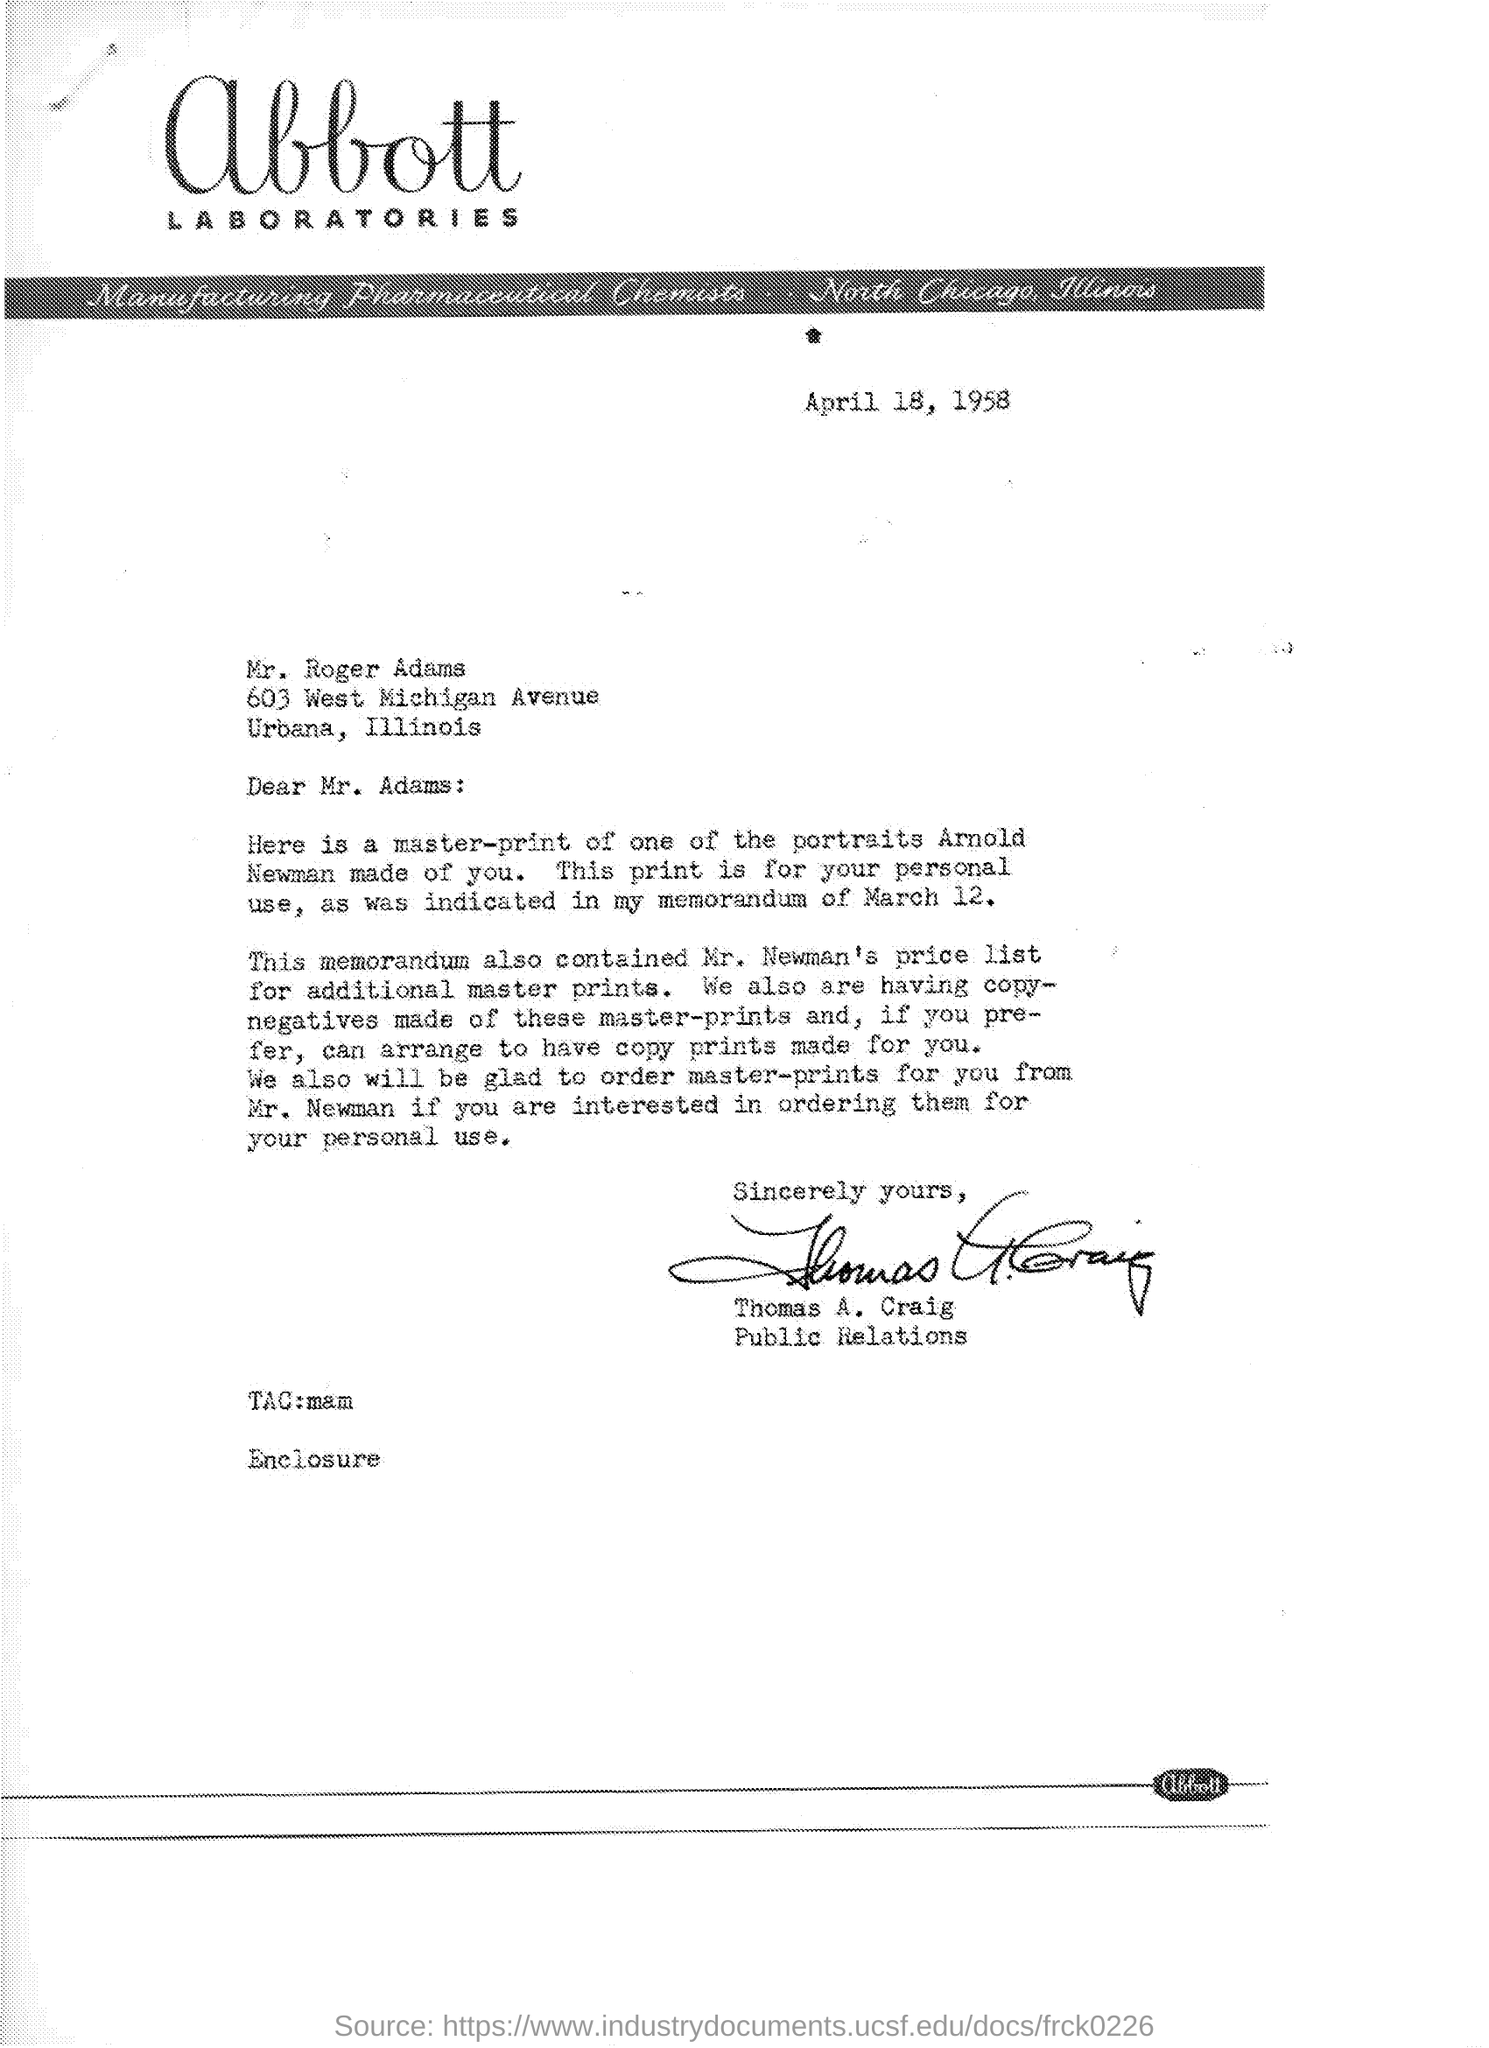Mention a couple of crucial points in this snapshot. The place called Urbanas is located in the state of Illinois. The sentence "Who is the sender? Thomas A. Craig.." can be rephrased as:

"The sender is Thomas A. Craig. The date of the memorandum was March 12.. 